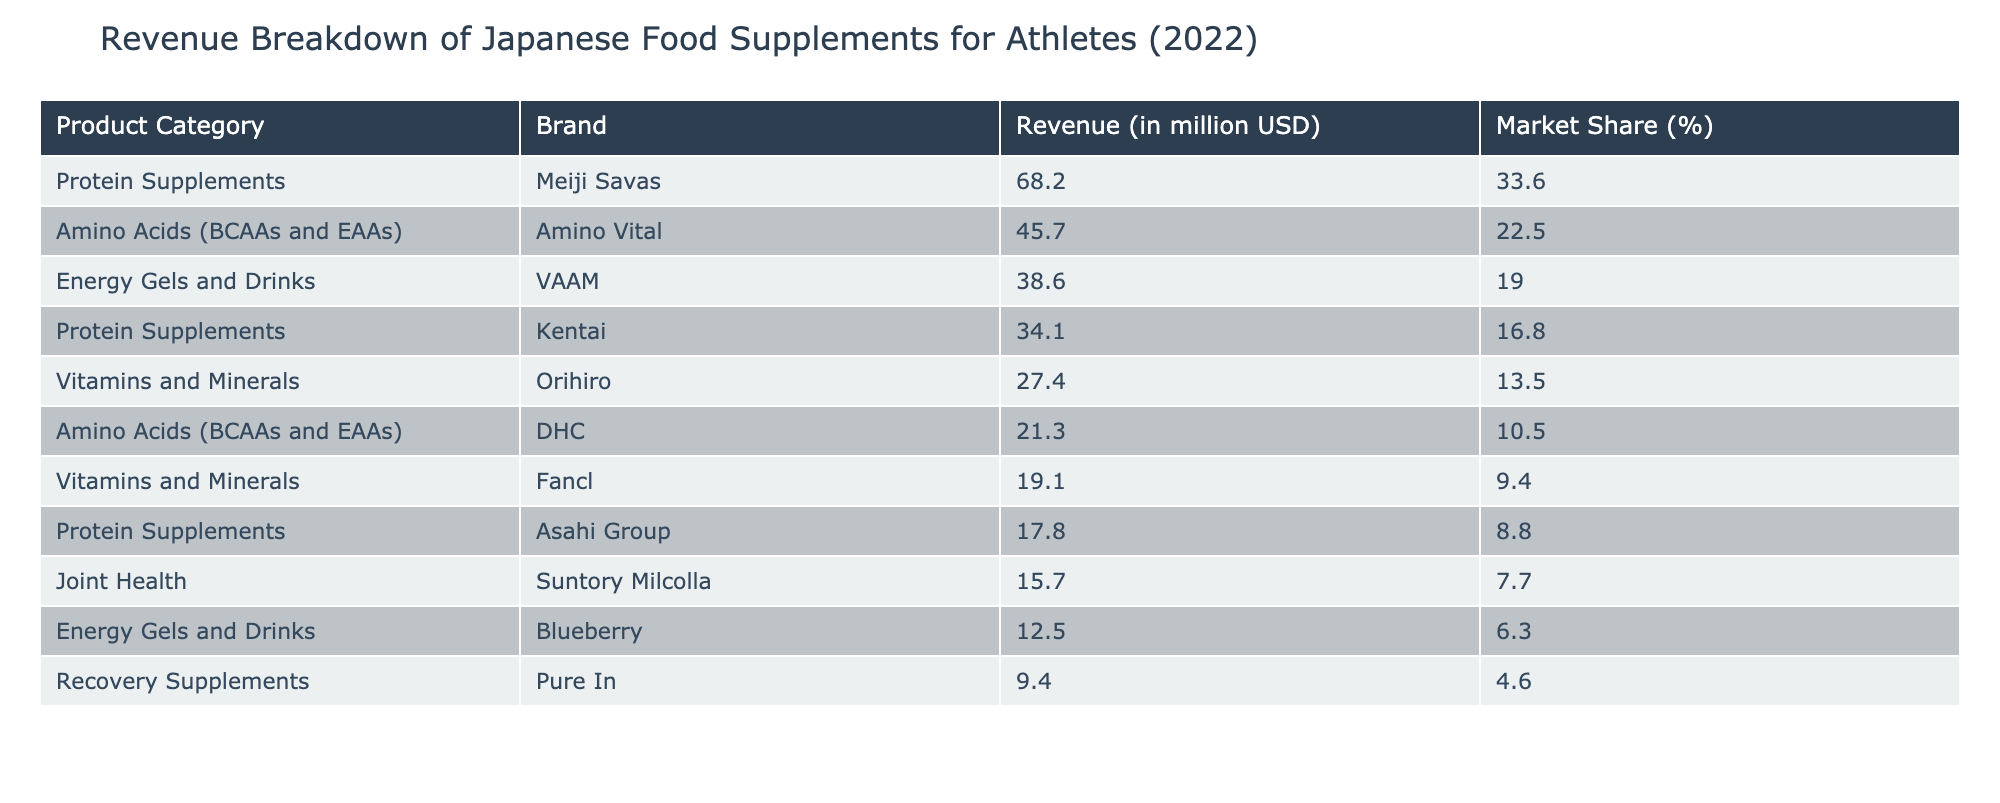What is the total revenue generated by Protein Supplements? To find the total revenue from Protein Supplements, we look at the rows corresponding to this category: Meiji Savas (68.2 million USD), Kentai (34.1 million USD), and Asahi Group (17.8 million USD). Summing these values: 68.2 + 34.1 + 17.8 = 120.1 million USD.
Answer: 120.1 million USD Which brand generated the highest revenue in the Amino Acids category? In the Amino Acids category, the brands listed are Amino Vital (45.7 million USD) and DHC (21.3 million USD). Comparing their revenues, Amino Vital has the higher revenue.
Answer: Amino Vital How much revenue was collected from Energy Gels and Drinks? The Energy Gels and Drinks category includes two brands: VAAM (38.6 million USD) and Blueberry (12.5 million USD). Adding these two revenues: 38.6 + 12.5 = 51.1 million USD gives us the total revenue for this category.
Answer: 51.1 million USD Is the market share of Orihiro greater than 10%? The market share of Orihiro, which generates 27.4 million USD in revenue, is listed as 13.5%. Since 13.5% is indeed greater than 10%, we conclude that the statement is true.
Answer: Yes What percentage of the total revenue comes from Vitamin and Mineral supplements? The total revenue from Vitamins and Minerals is: Orihiro (27.4 million USD) + Fancl (19.1 million USD) = 46.5 million USD. The total revenue across all categories can be calculated by summing each revenue: 45.7 + 21.3 + 68.2 + 34.1 + 17.8 + 27.4 + 19.1 + 38.6 + 12.5 + 9.4 + 15.7 =  394.5 million USD. To find the percentage, we divide the Vitamins and Minerals revenue by the total revenue and multiply by 100: (46.5 / 394.5) * 100 ≈ 11.8%.
Answer: Approximately 11.8% Which product category has the lowest total revenue? To determine the category with the lowest total revenue, we need to find the sum of revenues for each category. The Recovery Supplements category has a single brand, Pure In, which generates 9.4 million USD. Other categories have higher sums. Therefore, Recovery Supplements has the lowest revenue.
Answer: Recovery Supplements 